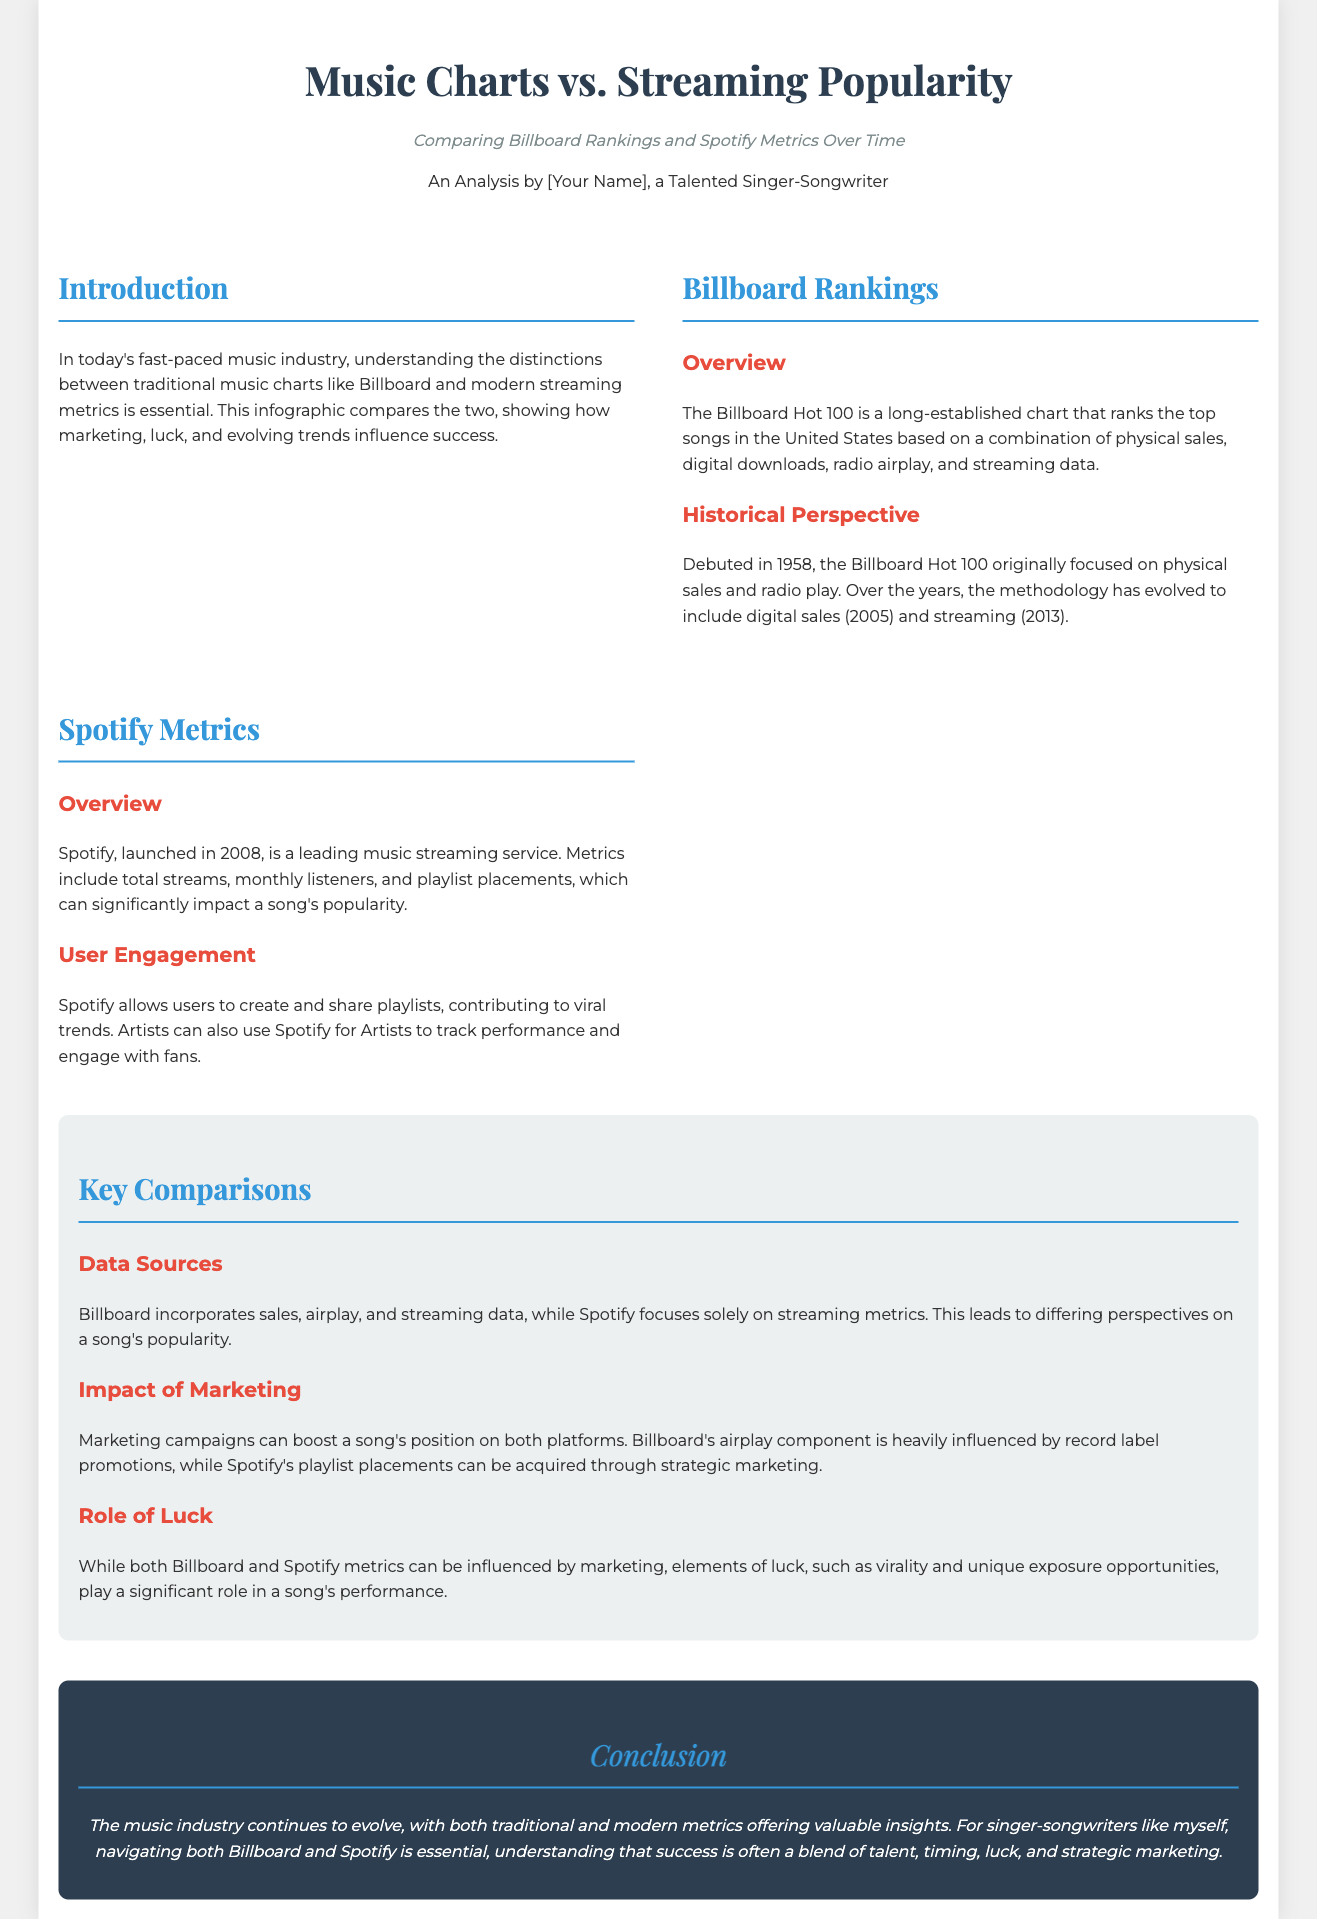what chart ranks the top songs in the United States? The document states that the Billboard Hot 100 ranks the top songs in the United States.
Answer: Billboard Hot 100 when did the Billboard Hot 100 debut? The document mentions that the Billboard Hot 100 debuted in 1958.
Answer: 1958 what year did Spotify launch? The document states that Spotify was launched in 2008.
Answer: 2008 what metrics does Spotify focus on? The document indicates that Spotify focuses on streaming metrics.
Answer: streaming metrics how has Billboard's methodology evolved since 1958? The document explains that Billboard's methodology has evolved to include digital sales in 2005 and streaming in 2013.
Answer: digital sales and streaming which type of campaigns can boost a song's position on both platforms? The document describes marketing campaigns as being able to boost a song's position on both platforms.
Answer: marketing campaigns what contributes to viral trends on Spotify? The document states that user-generated playlists contribute to viral trends on Spotify.
Answer: user-generated playlists what is essential for singer-songwriters navigating music success? The document concludes that navigating both Billboard and Spotify is essential for singer-songwriters.
Answer: navigating both Billboard and Spotify what does the conclusion of the document imply about music success? The conclusion implies that success is often a blend of talent, timing, luck, and strategic marketing.
Answer: talent, timing, luck, and strategic marketing 